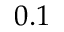<formula> <loc_0><loc_0><loc_500><loc_500>0 . 1</formula> 